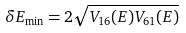Convert formula to latex. <formula><loc_0><loc_0><loc_500><loc_500>\delta E _ { \min } = 2 \sqrt { V _ { 1 6 } ( E ) V _ { 6 1 } ( E ) }</formula> 